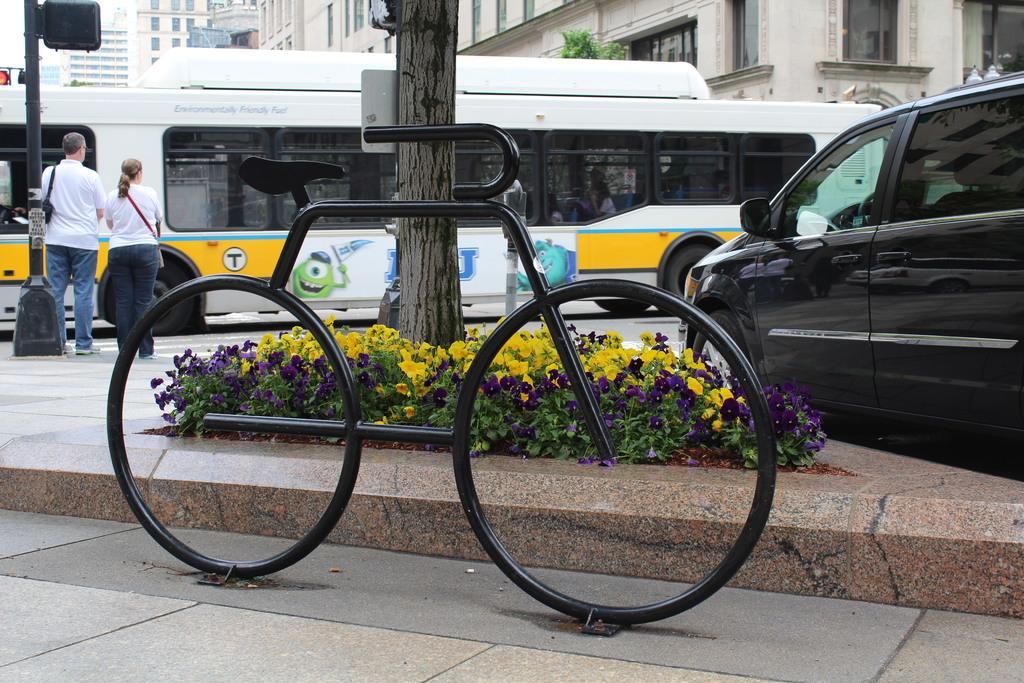In one or two sentences, can you explain what this image depicts? In the center of the image we can see a sculpture of a bicycle. There are plants and we can see flowers. In the background there are vehicles and buildings. On the left there are people standing. There is a pole. We can see trees. 